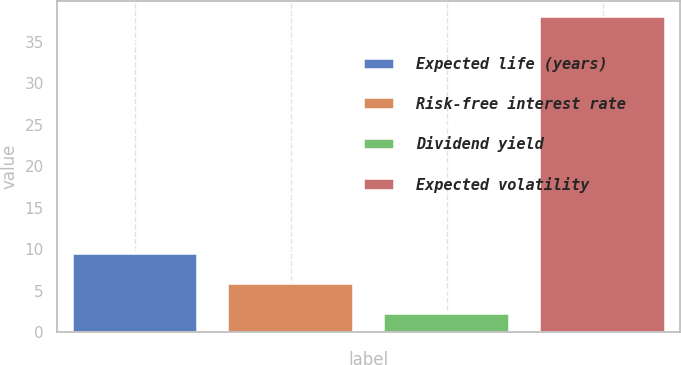<chart> <loc_0><loc_0><loc_500><loc_500><bar_chart><fcel>Expected life (years)<fcel>Risk-free interest rate<fcel>Dividend yield<fcel>Expected volatility<nl><fcel>9.36<fcel>5.78<fcel>2.2<fcel>38<nl></chart> 